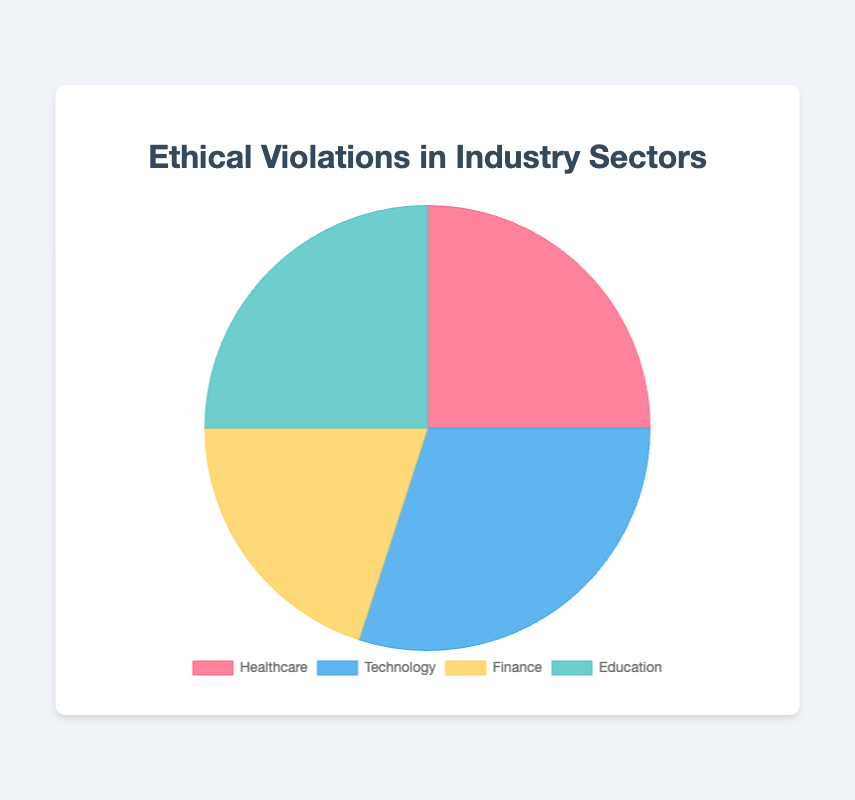Which sector has the highest percentage of ethical violations? The pie chart shows that the Technology sector has the highest slice. Therefore, Technology has the highest percentage of ethical violations.
Answer: Technology Which two sectors have an equal percentage of ethical violations? The chart shows that both the Healthcare and Education sectors have slices of equal size, indicating they have an equal percentage of ethical violations.
Answer: Healthcare and Education How much higher is the percentage of ethical violations in Technology compared to Finance? The percentage for Technology is 30% and for Finance is 20%. The difference in percentage is 30% - 20% = 10%.
Answer: 10% What is the combined percentage of ethical violations in Healthcare and Education? The percentage for Healthcare is 25% and for Education is also 25%. The combined percentage is 25% + 25% = 50%.
Answer: 50% What is the average percentage of ethical violations across all four industry sectors? The percentages are 25% (Healthcare), 30% (Technology), 20% (Finance), and 25% (Education). The sum is 25 + 30 + 20 + 25 = 100. The average is 100 / 4 = 25%.
Answer: 25% Which sector has the smallest slice in the pie chart? Looking at the pie chart, the smallest slice corresponds to the Finance sector.
Answer: Finance If the sectors were ranked from highest to lowest in terms of ethical violations, which position would the Finance sector hold? From the chart, Technology has the highest percentage, followed by Healthcare and Education (both equal), and then Finance. Hence, Finance holds the lowest position or 4th position.
Answer: 4th What is the total difference in percentage between the sector with the highest and the one with the lowest ethical violations? The highest is Technology with 30%, and the lowest is Finance with 20%. The difference is 30% - 20% = 10%.
Answer: 10% What portion of the chart is occupied by sectors with more than 20% ethical violations? The sectors with more than 20% are Healthcare (25%), Technology (30%), and Education (25%). The combined percentage is 25% + 30% + 25% = 80%.
Answer: 80% What color represents the sector with 20% ethical violations? Observing the chart, the Finance sector has 20% and is represented by yellow in the chart.
Answer: Yellow 